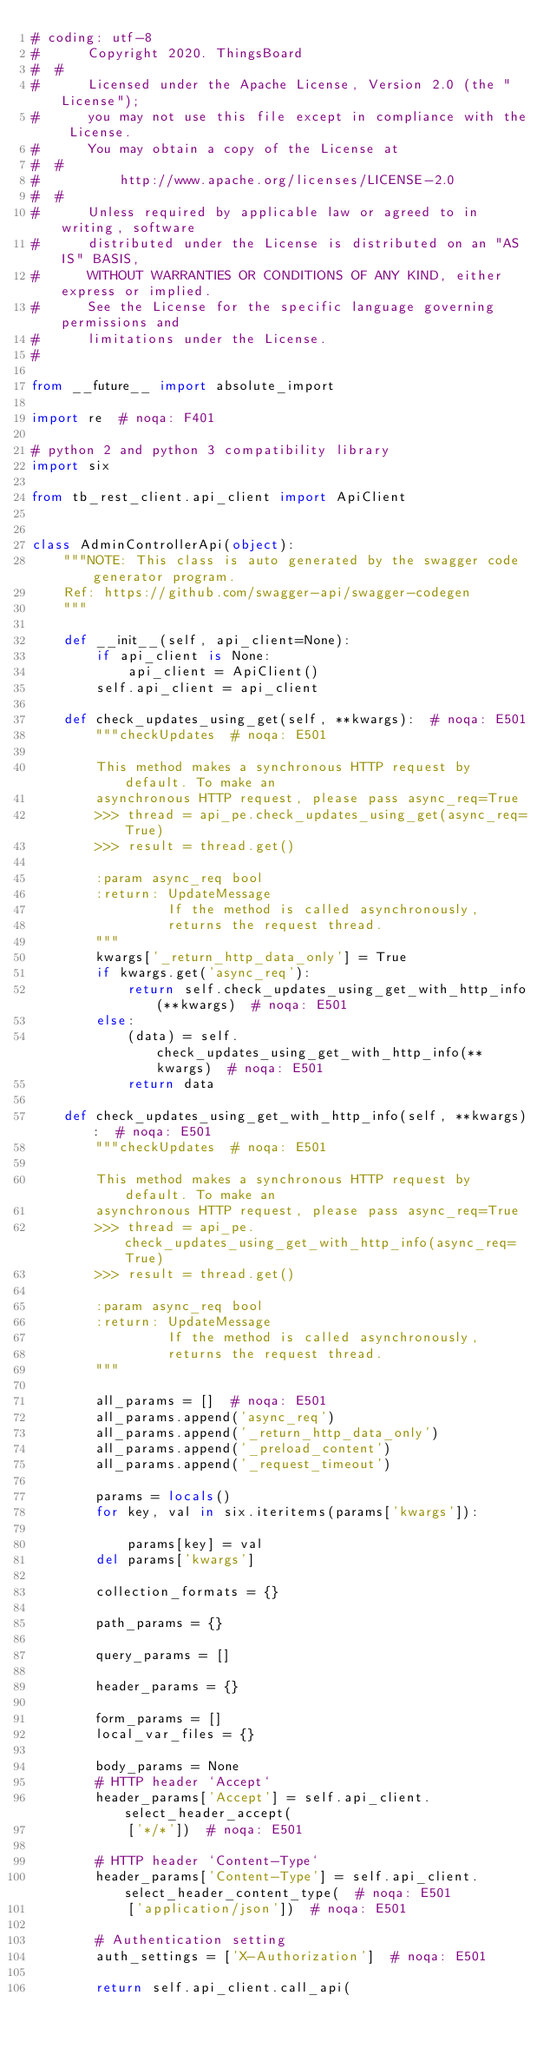Convert code to text. <code><loc_0><loc_0><loc_500><loc_500><_Python_># coding: utf-8
#      Copyright 2020. ThingsBoard
#  #
#      Licensed under the Apache License, Version 2.0 (the "License");
#      you may not use this file except in compliance with the License.
#      You may obtain a copy of the License at
#  #
#          http://www.apache.org/licenses/LICENSE-2.0
#  #
#      Unless required by applicable law or agreed to in writing, software
#      distributed under the License is distributed on an "AS IS" BASIS,
#      WITHOUT WARRANTIES OR CONDITIONS OF ANY KIND, either express or implied.
#      See the License for the specific language governing permissions and
#      limitations under the License.
#

from __future__ import absolute_import

import re  # noqa: F401

# python 2 and python 3 compatibility library
import six

from tb_rest_client.api_client import ApiClient


class AdminControllerApi(object):
    """NOTE: This class is auto generated by the swagger code generator program.    
    Ref: https://github.com/swagger-api/swagger-codegen
    """

    def __init__(self, api_client=None):
        if api_client is None:
            api_client = ApiClient()
        self.api_client = api_client

    def check_updates_using_get(self, **kwargs):  # noqa: E501
        """checkUpdates  # noqa: E501

        This method makes a synchronous HTTP request by default. To make an
        asynchronous HTTP request, please pass async_req=True
        >>> thread = api_pe.check_updates_using_get(async_req=True)
        >>> result = thread.get()

        :param async_req bool
        :return: UpdateMessage
                 If the method is called asynchronously,
                 returns the request thread.
        """
        kwargs['_return_http_data_only'] = True
        if kwargs.get('async_req'):
            return self.check_updates_using_get_with_http_info(**kwargs)  # noqa: E501
        else:
            (data) = self.check_updates_using_get_with_http_info(**kwargs)  # noqa: E501
            return data

    def check_updates_using_get_with_http_info(self, **kwargs):  # noqa: E501
        """checkUpdates  # noqa: E501

        This method makes a synchronous HTTP request by default. To make an
        asynchronous HTTP request, please pass async_req=True
        >>> thread = api_pe.check_updates_using_get_with_http_info(async_req=True)
        >>> result = thread.get()

        :param async_req bool
        :return: UpdateMessage
                 If the method is called asynchronously,
                 returns the request thread.
        """

        all_params = []  # noqa: E501
        all_params.append('async_req')
        all_params.append('_return_http_data_only')
        all_params.append('_preload_content')
        all_params.append('_request_timeout')

        params = locals()
        for key, val in six.iteritems(params['kwargs']):
            
            params[key] = val
        del params['kwargs']

        collection_formats = {}

        path_params = {}

        query_params = []

        header_params = {}

        form_params = []
        local_var_files = {}

        body_params = None
        # HTTP header `Accept`
        header_params['Accept'] = self.api_client.select_header_accept(
            ['*/*'])  # noqa: E501

        # HTTP header `Content-Type`
        header_params['Content-Type'] = self.api_client.select_header_content_type(  # noqa: E501
            ['application/json'])  # noqa: E501

        # Authentication setting
        auth_settings = ['X-Authorization']  # noqa: E501

        return self.api_client.call_api(</code> 